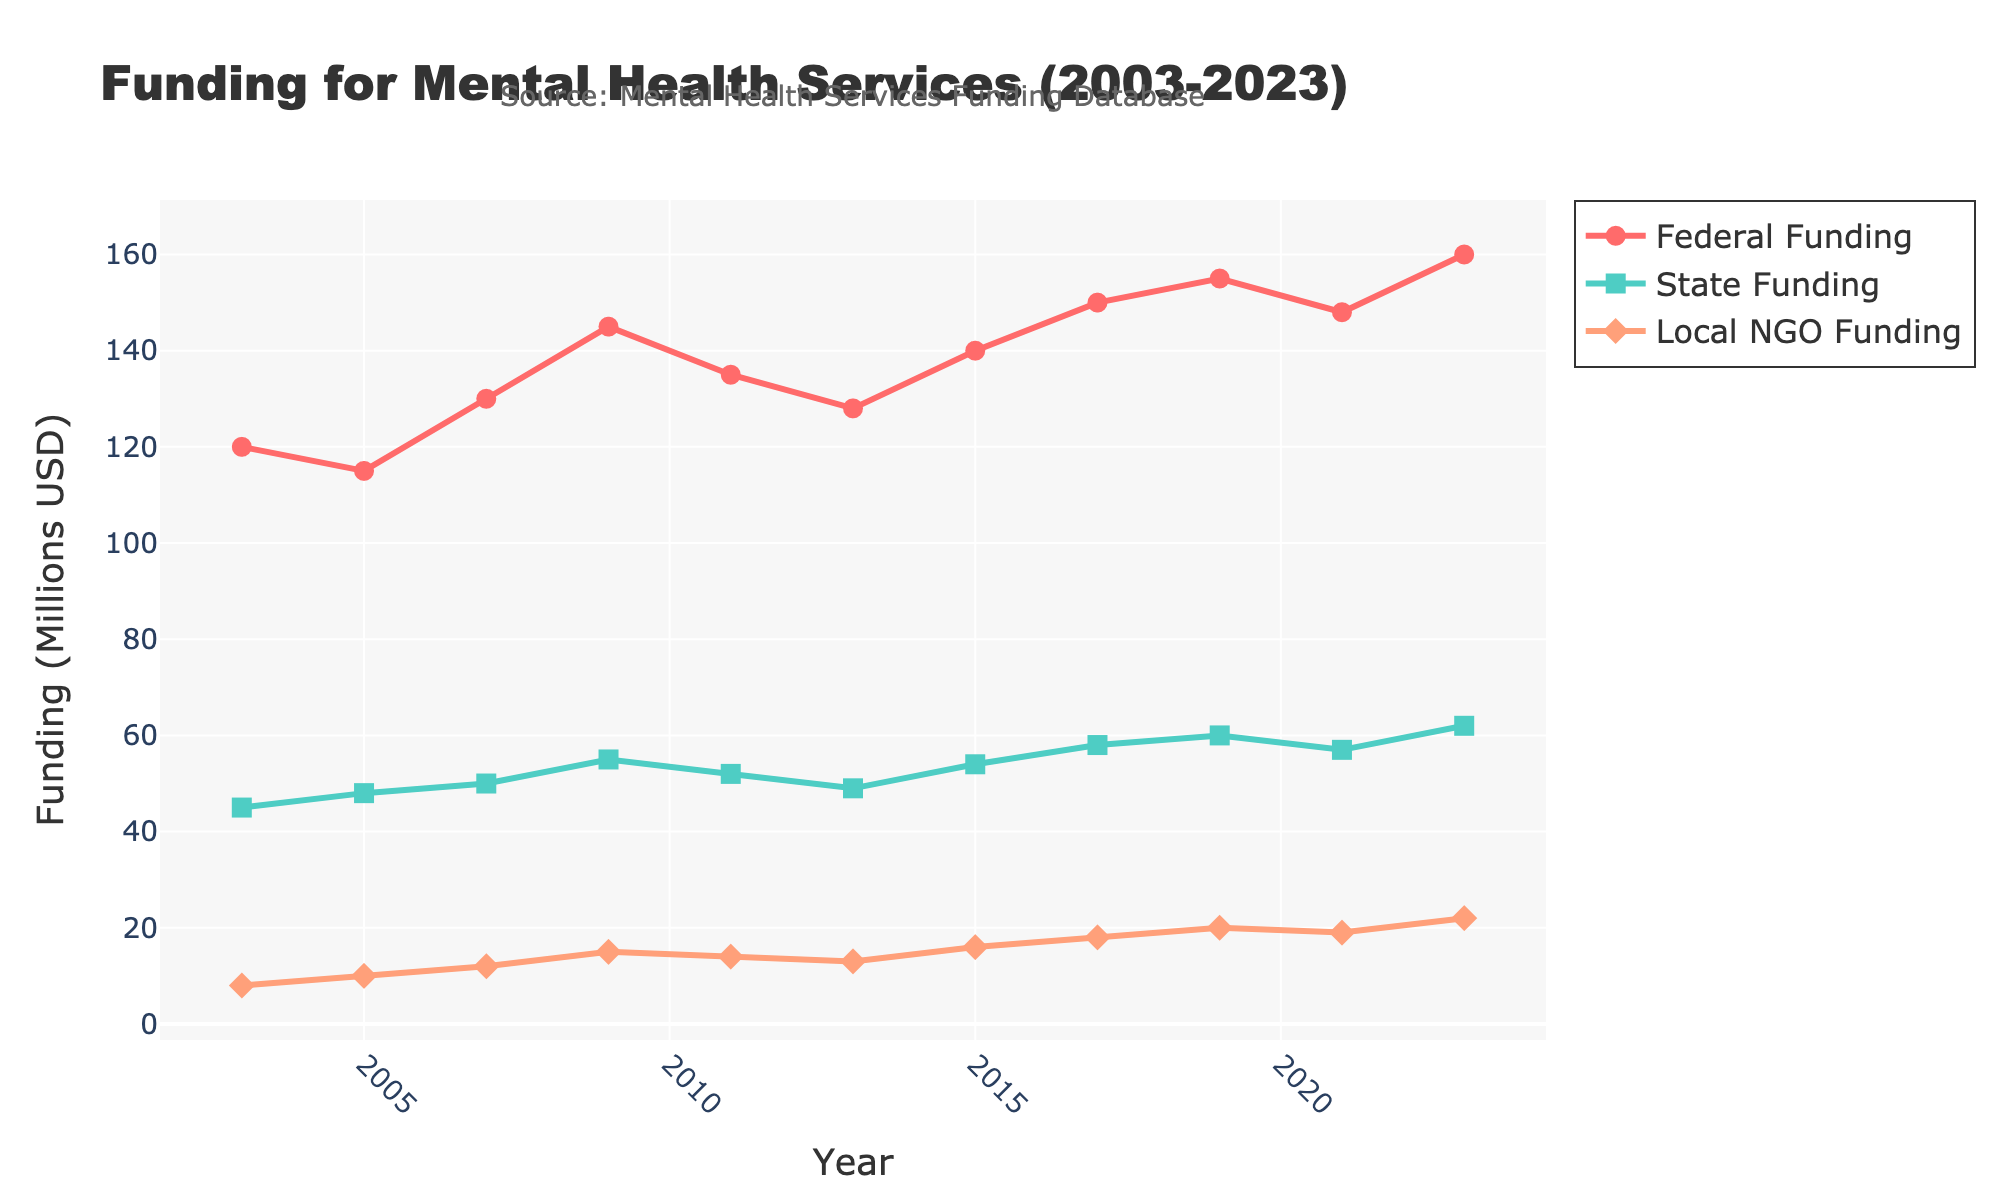What was the total amount of funding from all sources in 2023? Sum the funds from all sources in 2023: Federal ($160M), State ($62M), and Local NGO ($22M). So, 160 + 62 + 22 = 244.
Answer: 244 During which year did State Funding see its maximum value? Look at the State Funding line and identify the peak value. The highest point on the plot is at the year 2023 with $62M.
Answer: 2023 Compare the Federal Funding in 2011 with that in 2021. Which year had higher funding and by how much? Federal Funding in 2011 was $135M, and in 2021 was $148M. Compute the difference: 148 - 135 = 13.
Answer: 2021 by 13 What is the average State Funding over the period displayed? Sum all the State Funding values: 45+48+50+55+52+49+54+58+60+57+62 = 590. Divide by the number of years (11): 590 / 11 ≈ 53.6.
Answer: 53.6 Was there ever a year when Local NGO Funding was higher than $20M? If so, specify the year(s) and the funding amount. Look at each data point for Local NGO Funding to check if any are above $20M. In 2023, Local NGO Funding was $22M.
Answer: 2023, $22M What was the trend in Federal Funding between 2009 and 2013? Refer to the Federal Funding line from 2009 ($145M), 2011 ($135M), to 2013 ($128M). The trend shows a decline over the years.
Answer: Decreasing In which year did the Local NGO Funding first reach $10M? Check each year for Local NGO Funding to find the first instance of a value at or above $10M. This occurred in 2005 with $10M.
Answer: 2005 How did the State Funding change from 2003 to 2007? Check the State Funding at 2003 ($45M) and 2007 ($50M). The change is calculated as 50 - 45 = 5.
Answer: Increased by 5 What is the difference in total funding (all sources combined) between 2003 and 2009? Calculate total funding for both years: 2003 (120 + 45 + 8 = 173), 2009 (145 + 55 + 15 = 215); difference is 215 - 173 = 42.
Answer: 42 Did any funding source decrease from 2019 to 2021? If yes, which one and by how much? Federal Funding: 155M to 148M, difference of 7M. State Funding: 60M to 57M, difference of 3M. Local NGO Funding: 20M to 19M, difference of 1M. All three decreased.
Answer: Federal Funding by 7, State Funding by 3, Local NGO Funding by 1 